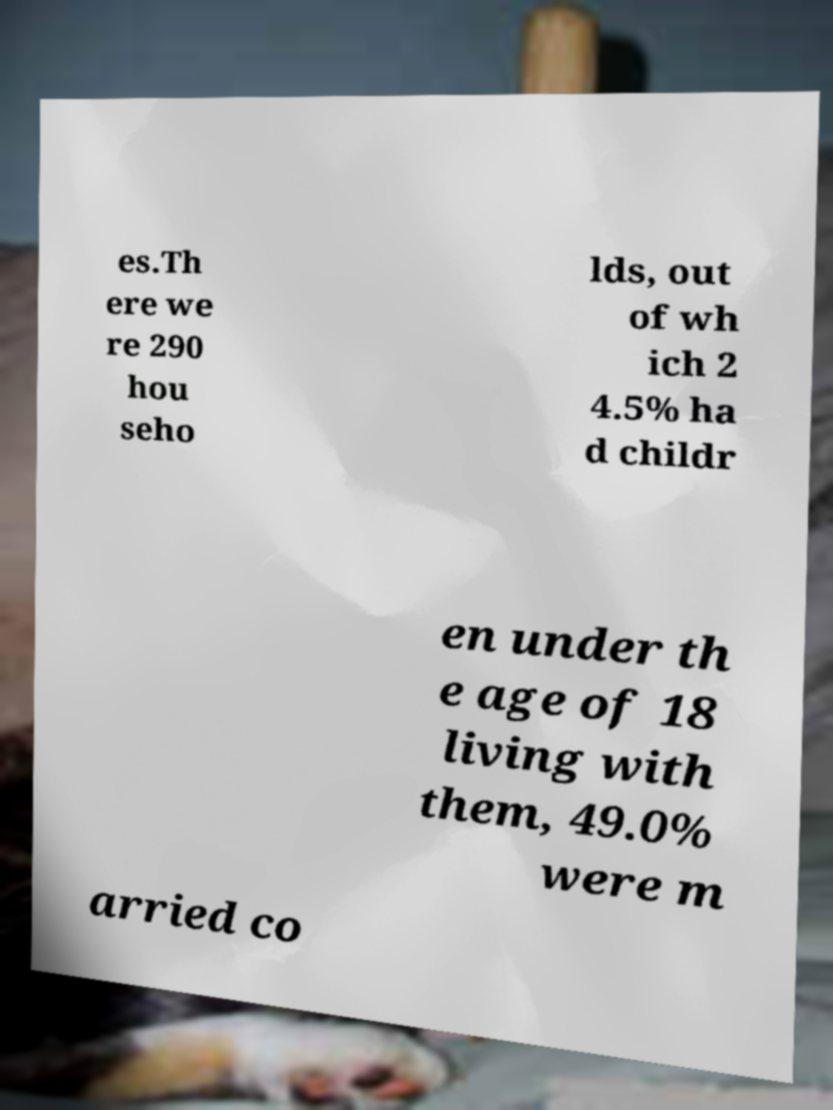What messages or text are displayed in this image? I need them in a readable, typed format. es.Th ere we re 290 hou seho lds, out of wh ich 2 4.5% ha d childr en under th e age of 18 living with them, 49.0% were m arried co 